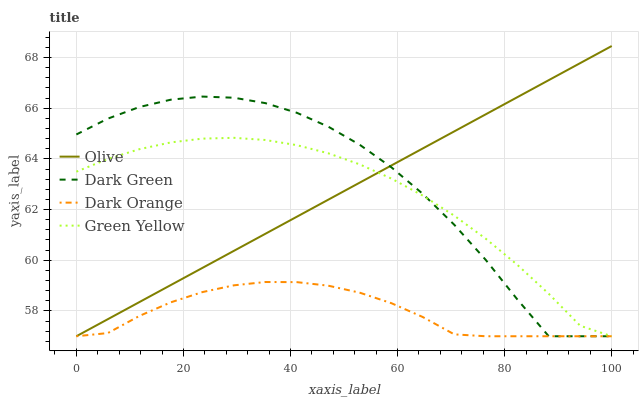Does Dark Orange have the minimum area under the curve?
Answer yes or no. Yes. Does Dark Green have the maximum area under the curve?
Answer yes or no. Yes. Does Green Yellow have the minimum area under the curve?
Answer yes or no. No. Does Green Yellow have the maximum area under the curve?
Answer yes or no. No. Is Olive the smoothest?
Answer yes or no. Yes. Is Dark Green the roughest?
Answer yes or no. Yes. Is Dark Orange the smoothest?
Answer yes or no. No. Is Dark Orange the roughest?
Answer yes or no. No. Does Olive have the lowest value?
Answer yes or no. Yes. Does Olive have the highest value?
Answer yes or no. Yes. Does Green Yellow have the highest value?
Answer yes or no. No. Does Dark Green intersect Olive?
Answer yes or no. Yes. Is Dark Green less than Olive?
Answer yes or no. No. Is Dark Green greater than Olive?
Answer yes or no. No. 